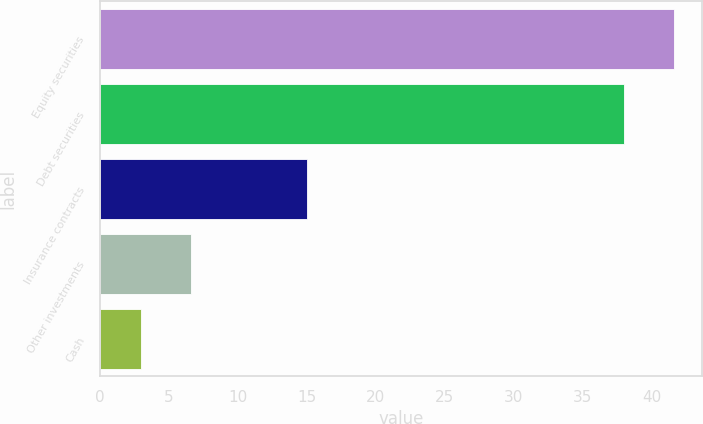Convert chart. <chart><loc_0><loc_0><loc_500><loc_500><bar_chart><fcel>Equity securities<fcel>Debt securities<fcel>Insurance contracts<fcel>Other investments<fcel>Cash<nl><fcel>41.6<fcel>38<fcel>15<fcel>6.6<fcel>3<nl></chart> 